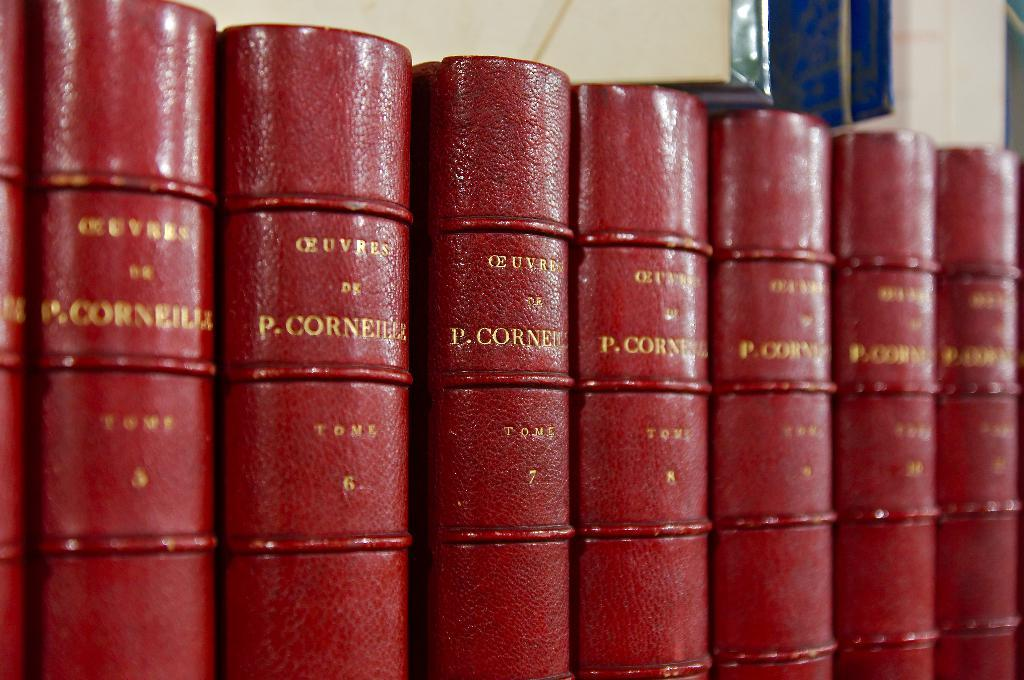<image>
Create a compact narrative representing the image presented. A group of red books which is by an author that's name begins with P but second name is too difficult to see. 